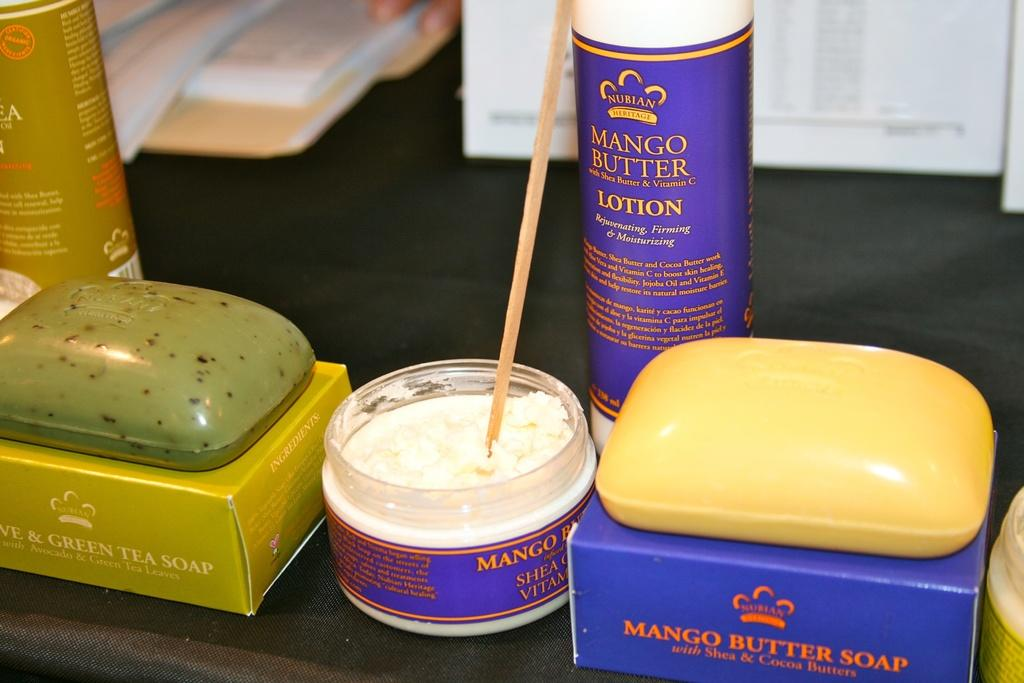<image>
Give a short and clear explanation of the subsequent image. A close up of a selection of Mango and Green Tea soaps and lotions. 